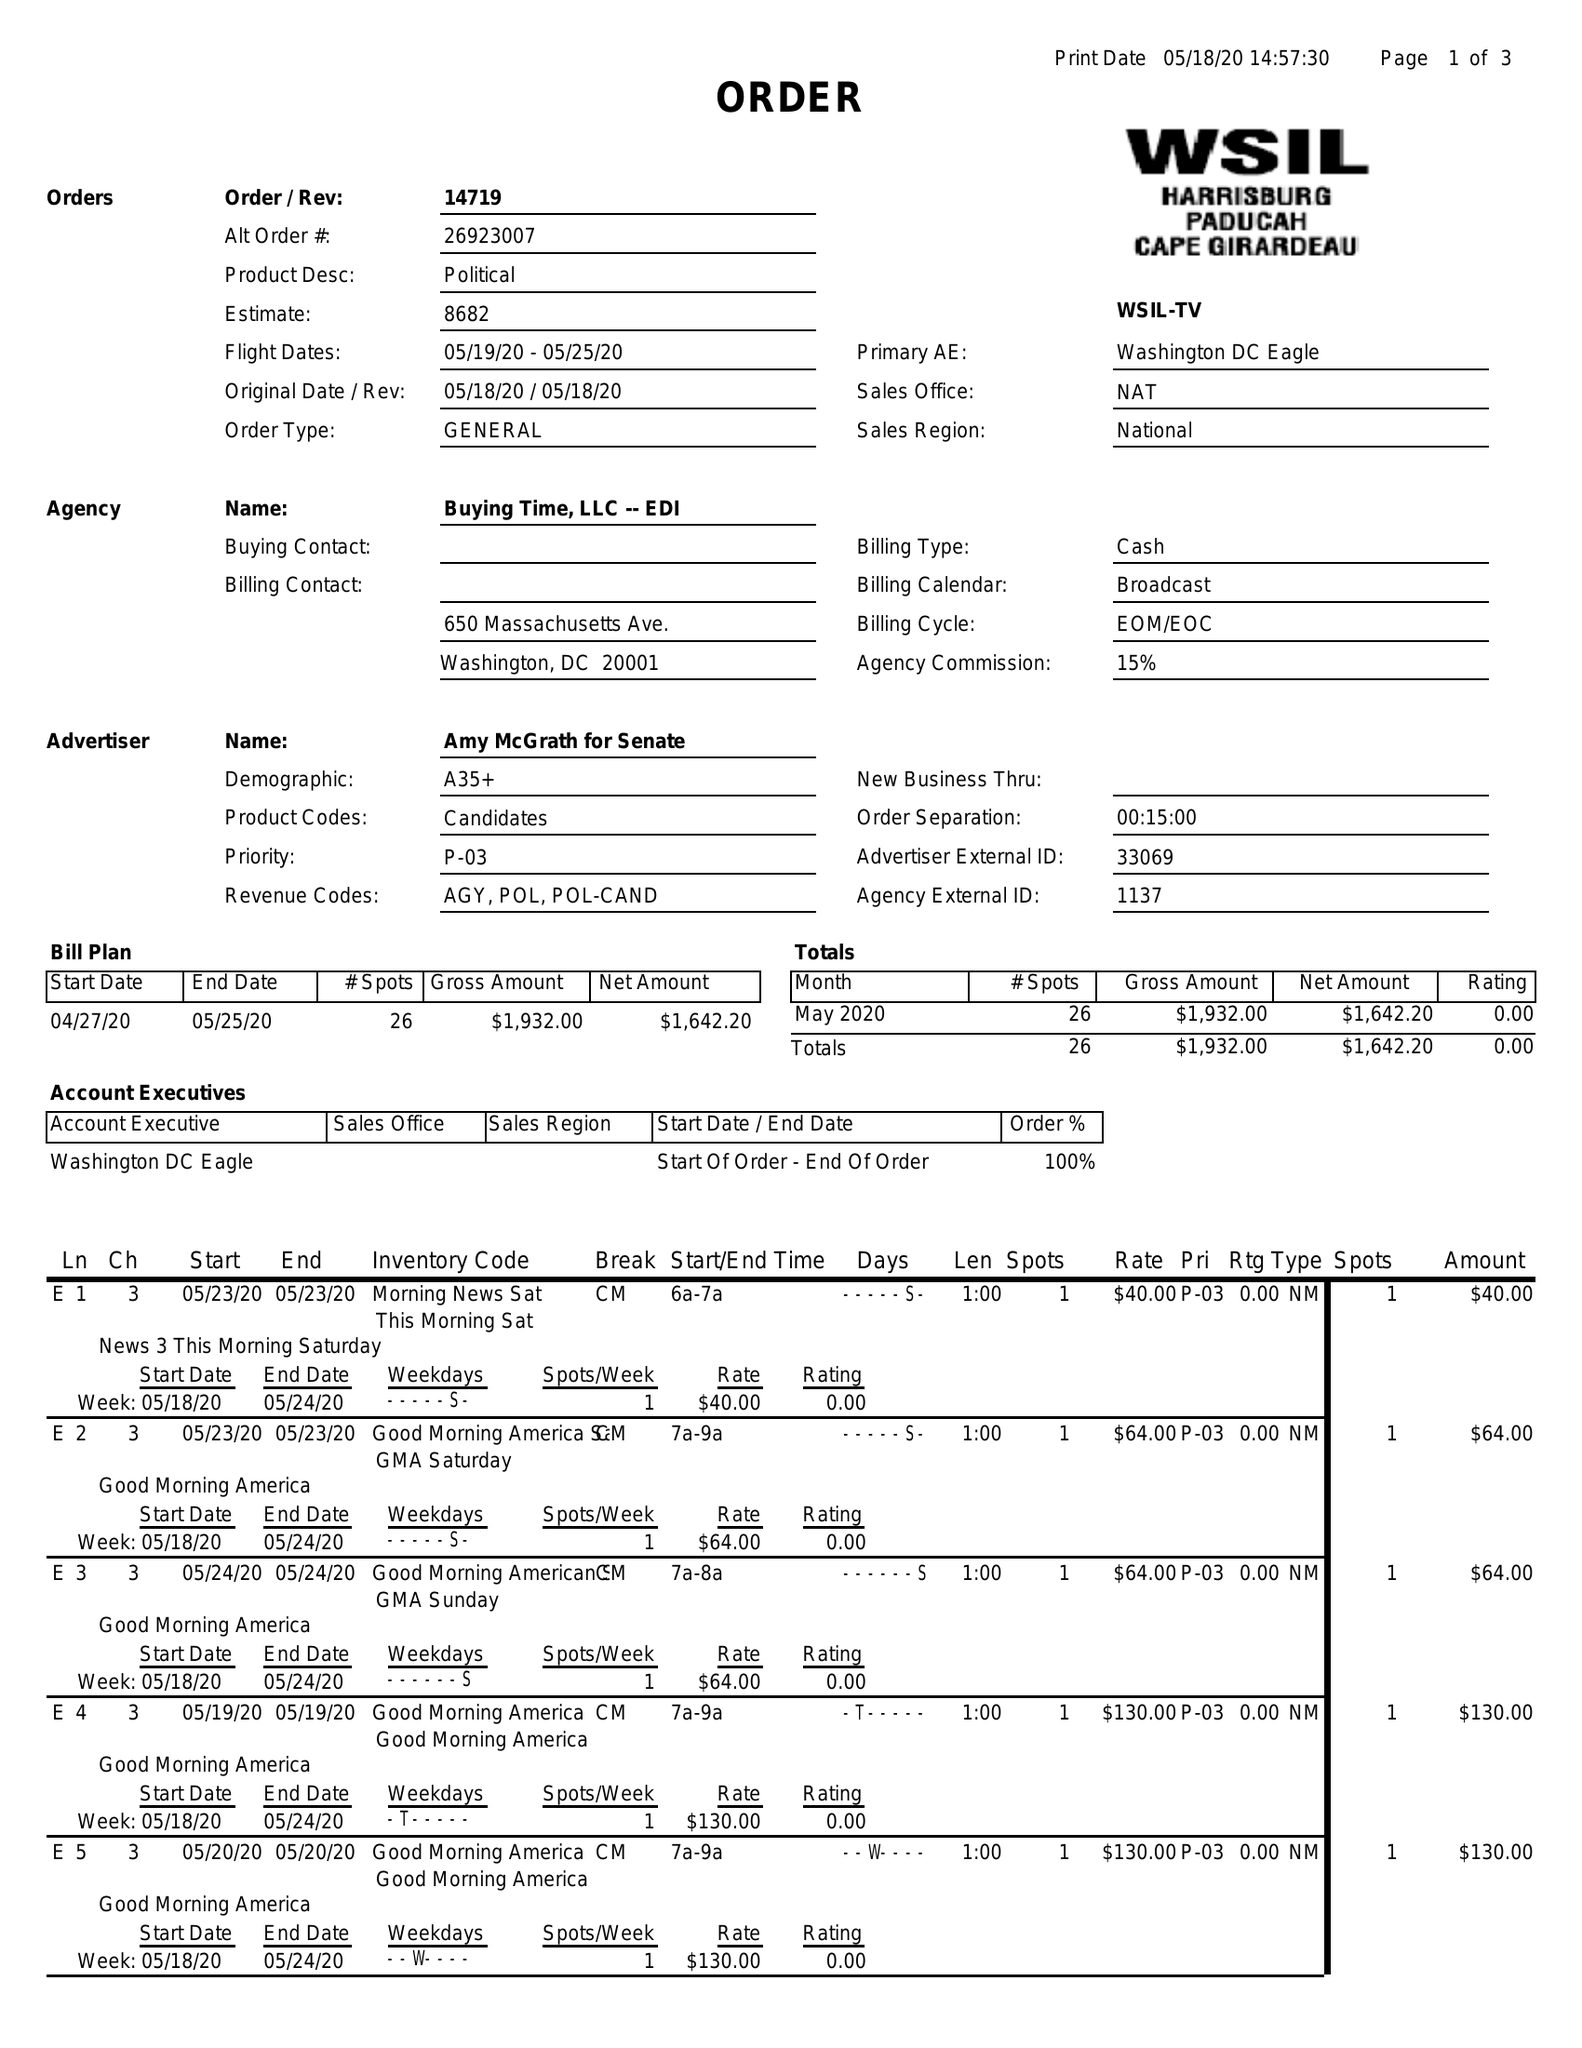What is the value for the flight_to?
Answer the question using a single word or phrase. 05/25/20 